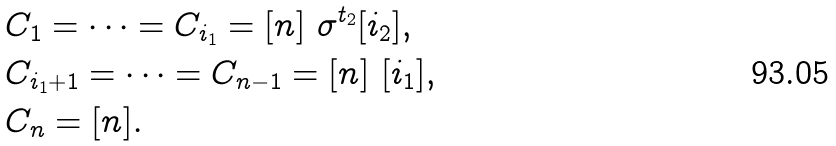Convert formula to latex. <formula><loc_0><loc_0><loc_500><loc_500>& C _ { 1 } = \dots = C _ { i _ { 1 } } = [ n ] \ \sigma ^ { t _ { 2 } } [ i _ { 2 } ] , \\ & C _ { i _ { 1 } + 1 } = \dots = C _ { n - 1 } = [ n ] \ [ i _ { 1 } ] , \\ & C _ { n } = [ n ] .</formula> 